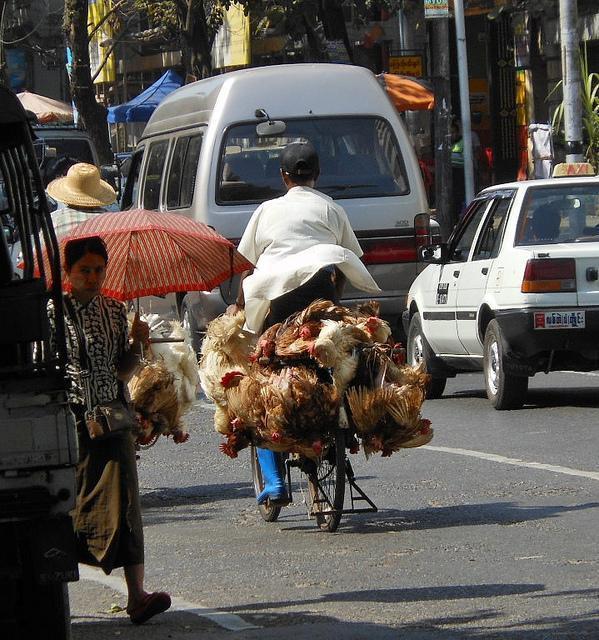What does the man on the bike do for a living?
Indicate the correct choice and explain in the format: 'Answer: answer
Rationale: rationale.'
Options: Gives rides, sells bikes, sells chickens, steals bikes. Answer: sells chickens.
Rationale: The man has chickens on the bike. 